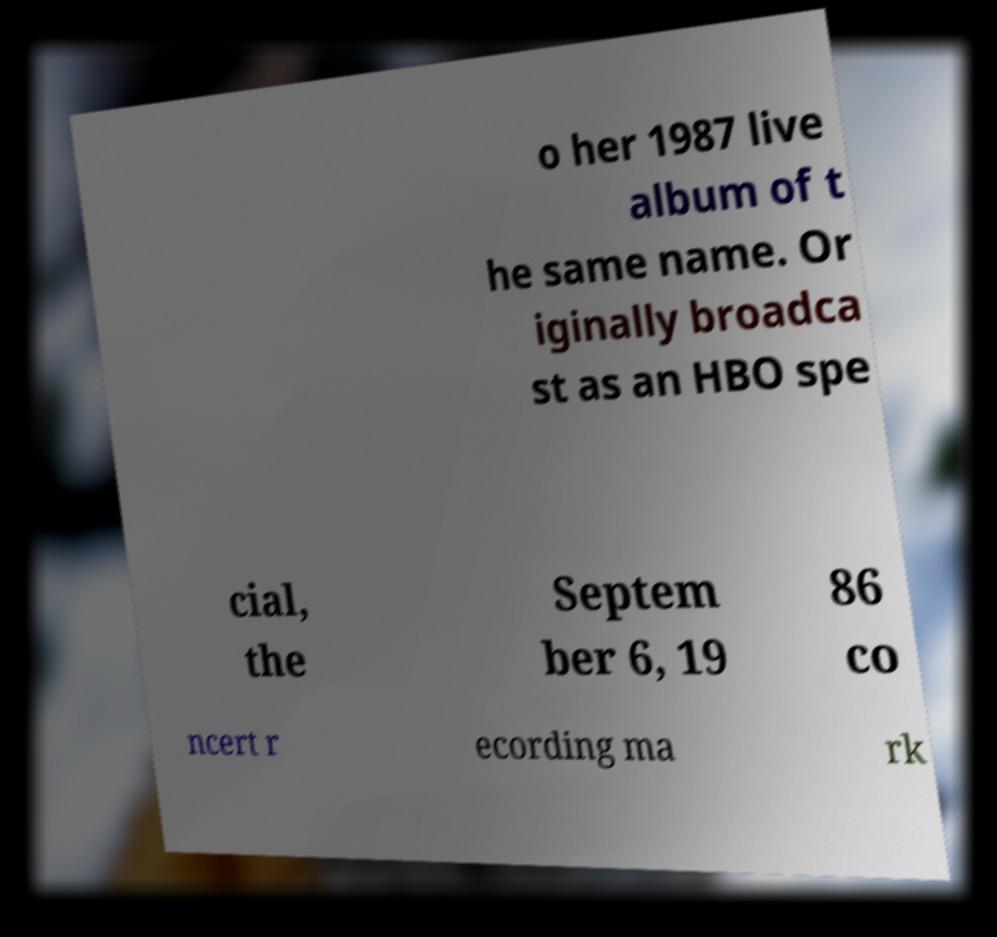Please identify and transcribe the text found in this image. o her 1987 live album of t he same name. Or iginally broadca st as an HBO spe cial, the Septem ber 6, 19 86 co ncert r ecording ma rk 